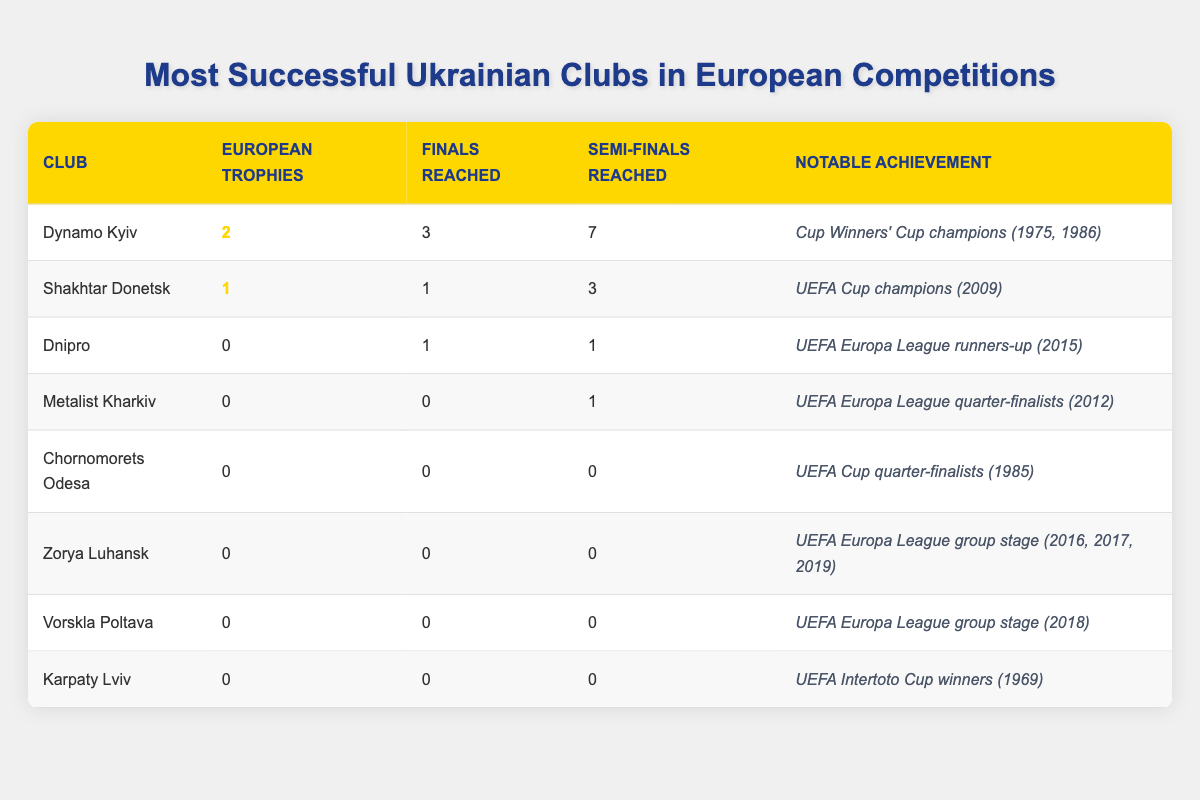What Ukrainian club has the most European trophies? From the table, Dynamo Kyiv has 2 European trophies, which is more than any other club listed.
Answer: Dynamo Kyiv How many times has Shakhtar Donetsk reached the finals? Referring to the table, Shakhtar Donetsk has reached the finals 1 time.
Answer: 1 Which club reached the semi-finals the most times? Looking at the table, Dynamo Kyiv reached the semi-finals 7 times, more than any other club.
Answer: 7 Did any Ukrainian club win a European trophy? According to the table, only Dynamo Kyiv and Shakhtar Donetsk won trophies, thus confirming the positive response.
Answer: Yes What is the notable achievement of Dnipro? The table indicates that Dnipro was the UEFA Europa League runners-up in 2015, which is its notable achievement.
Answer: UEFA Europa League runners-up (2015) If we sum the number of finals reached by all clubs, what do we get? Adding the finals reached: 3 (Dynamo Kyiv) + 1 (Shakhtar Donetsk) + 1 (Dnipro) = 5 in total. Other clubs did not reach any finals.
Answer: 5 Are there any clubs that have both no European trophies and have not reached any finals? According to the table, clubs like Metalist Kharkiv, Chornomorets Odesa, Zorya Luhansk, Vorskla Poltava, and Karpaty Lviv have no trophies and have not reached finals.
Answer: Yes What is the average number of semi-finals reached by the clubs listed? To calculate the average, we take the total of semi-finals reached (7 + 3 + 1 = 11) and divide it by the number of clubs (8), which gives us an average of 11/8 = 1.375.
Answer: 1.375 Which club has the least notable achievements? By reviewing the table, Chornomorets Odesa and Zorya Luhansk both reached no rounds beyond group stages and have no trophies, indicating minimal notable achievements.
Answer: Chornomorets Odesa and Zorya Luhansk 